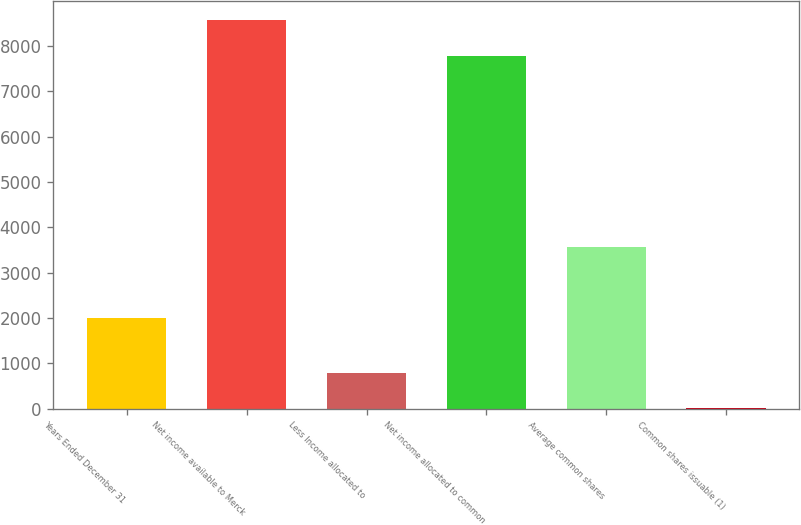<chart> <loc_0><loc_0><loc_500><loc_500><bar_chart><fcel>Years Ended December 31<fcel>Net income available to Merck<fcel>Less Income allocated to<fcel>Net income allocated to common<fcel>Average common shares<fcel>Common shares issuable (1)<nl><fcel>2008<fcel>8567.77<fcel>786.87<fcel>7787.6<fcel>3568.34<fcel>6.7<nl></chart> 